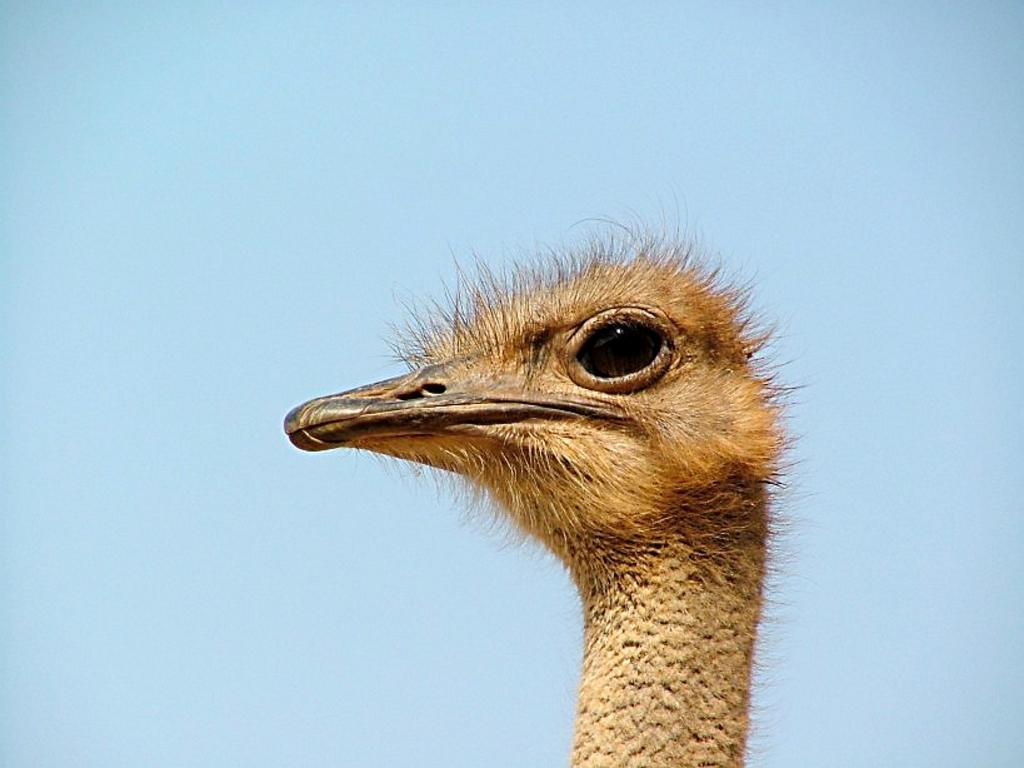What type of animal can be seen in the image? There is a bird in the image. What can be seen in the background of the image? The sky is visible in the background of the image. What type of stamp is the bird using to fly in the image? There is no stamp present in the image, and birds do not use stamps to fly. 